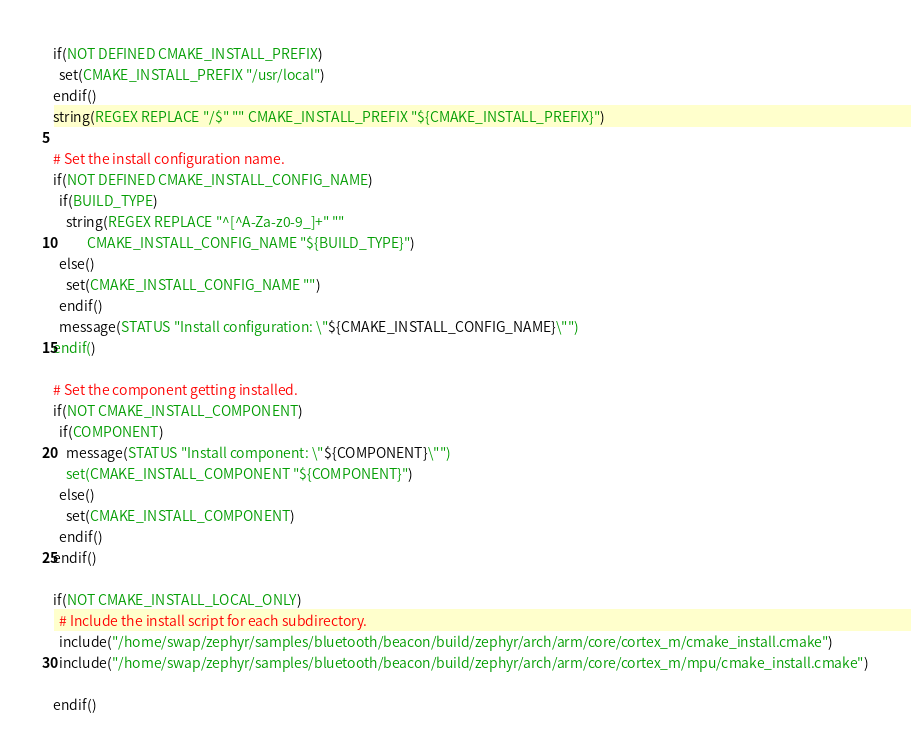<code> <loc_0><loc_0><loc_500><loc_500><_CMake_>if(NOT DEFINED CMAKE_INSTALL_PREFIX)
  set(CMAKE_INSTALL_PREFIX "/usr/local")
endif()
string(REGEX REPLACE "/$" "" CMAKE_INSTALL_PREFIX "${CMAKE_INSTALL_PREFIX}")

# Set the install configuration name.
if(NOT DEFINED CMAKE_INSTALL_CONFIG_NAME)
  if(BUILD_TYPE)
    string(REGEX REPLACE "^[^A-Za-z0-9_]+" ""
           CMAKE_INSTALL_CONFIG_NAME "${BUILD_TYPE}")
  else()
    set(CMAKE_INSTALL_CONFIG_NAME "")
  endif()
  message(STATUS "Install configuration: \"${CMAKE_INSTALL_CONFIG_NAME}\"")
endif()

# Set the component getting installed.
if(NOT CMAKE_INSTALL_COMPONENT)
  if(COMPONENT)
    message(STATUS "Install component: \"${COMPONENT}\"")
    set(CMAKE_INSTALL_COMPONENT "${COMPONENT}")
  else()
    set(CMAKE_INSTALL_COMPONENT)
  endif()
endif()

if(NOT CMAKE_INSTALL_LOCAL_ONLY)
  # Include the install script for each subdirectory.
  include("/home/swap/zephyr/samples/bluetooth/beacon/build/zephyr/arch/arm/core/cortex_m/cmake_install.cmake")
  include("/home/swap/zephyr/samples/bluetooth/beacon/build/zephyr/arch/arm/core/cortex_m/mpu/cmake_install.cmake")

endif()

</code> 